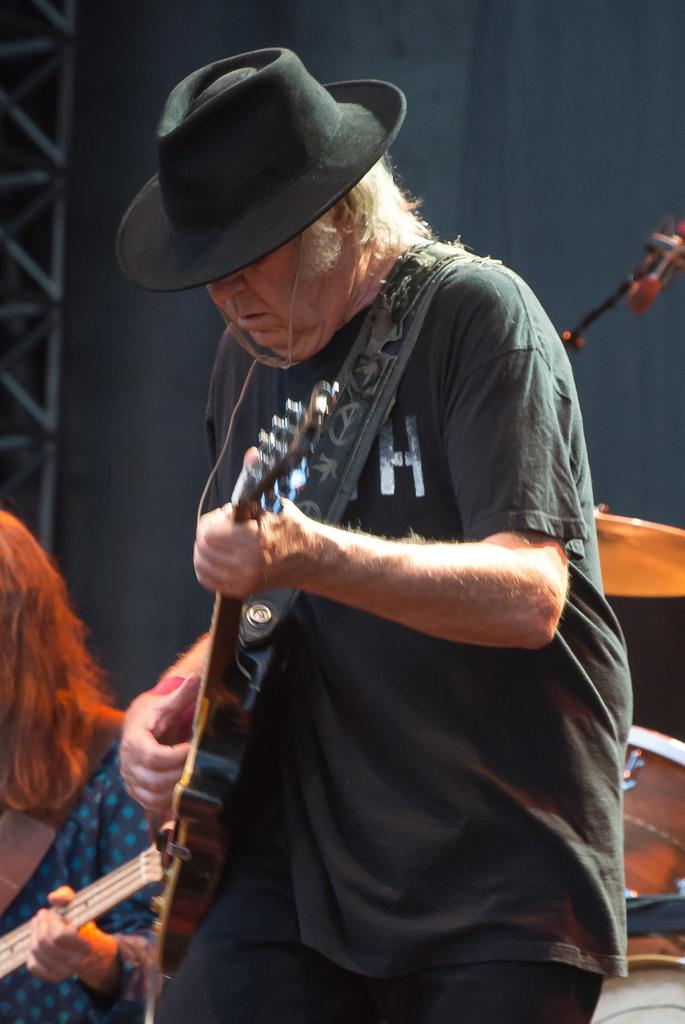What is the man in the image doing? The man is standing and playing a guitar in the image. Who else is present in the image? There is a woman seated in the image. What is the woman holding in her hand? The woman is holding a guitar in her hand. How many boys are present in the image? There is no boy present in the image; it features a man and a woman. What type of stretch is the woman performing in the image? There is no stretch being performed in the image; the woman is seated and holding a guitar. 